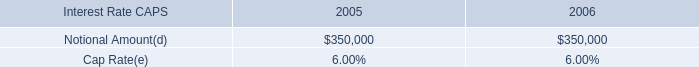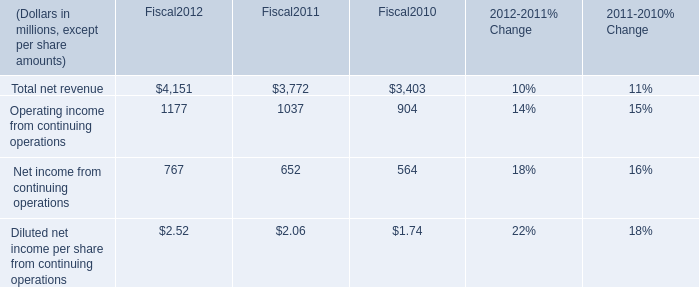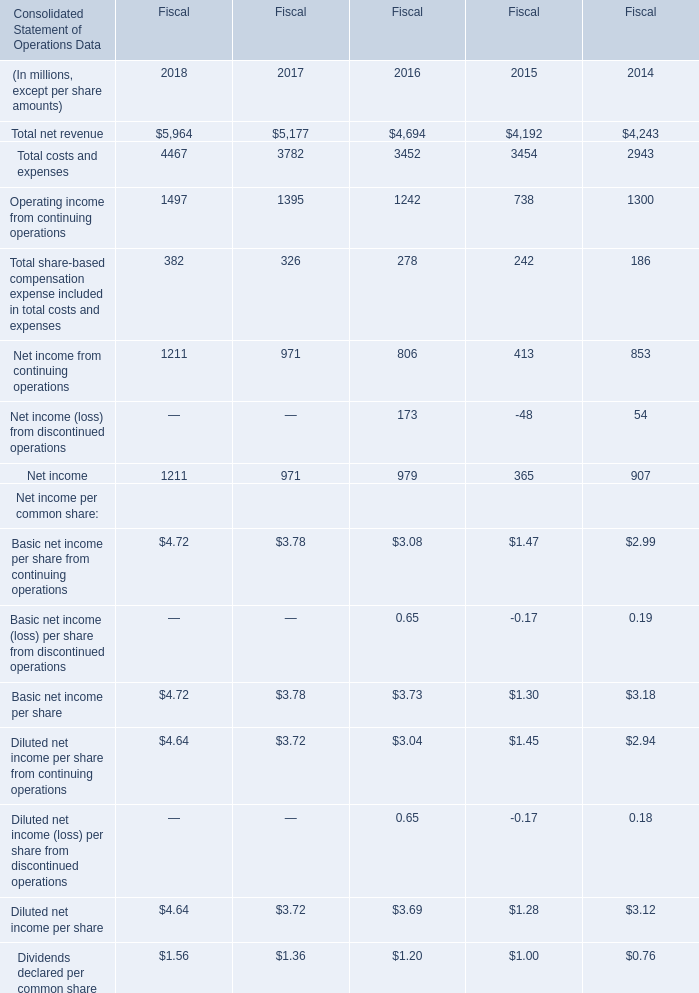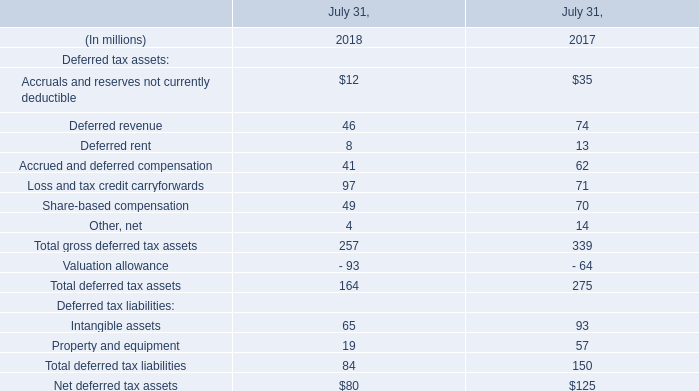what's the total amount of Operating income from continuing operations of Fiscal 2016, Operating income from continuing operations of Fiscal2012, and Operating income from continuing operations of Fiscal 2014 ? 
Computations: ((1242.0 + 1177.0) + 1300.0)
Answer: 3719.0. In which year is Net income (loss) from discontinued operations positive? 
Answer: 2016 2014. 